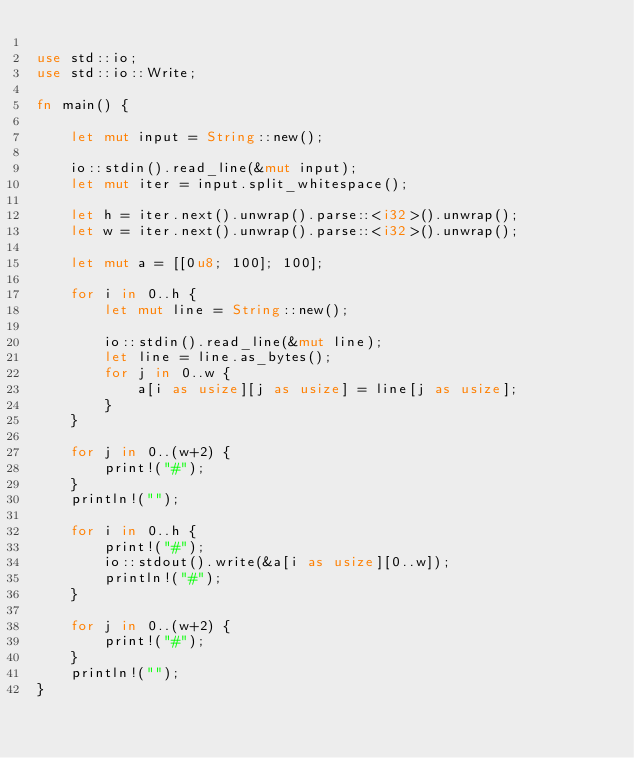<code> <loc_0><loc_0><loc_500><loc_500><_Rust_>
use std::io;
use std::io::Write;

fn main() {

    let mut input = String::new();

    io::stdin().read_line(&mut input);
    let mut iter = input.split_whitespace();

    let h = iter.next().unwrap().parse::<i32>().unwrap();
    let w = iter.next().unwrap().parse::<i32>().unwrap();

    let mut a = [[0u8; 100]; 100];

    for i in 0..h {
        let mut line = String::new();

        io::stdin().read_line(&mut line);
        let line = line.as_bytes();
        for j in 0..w {
            a[i as usize][j as usize] = line[j as usize];
        }
    }

    for j in 0..(w+2) {
        print!("#");
    }
    println!("");

    for i in 0..h {
        print!("#");
        io::stdout().write(&a[i as usize][0..w]);
        println!("#");
    }

    for j in 0..(w+2) {
        print!("#");
    }
    println!("");
}</code> 